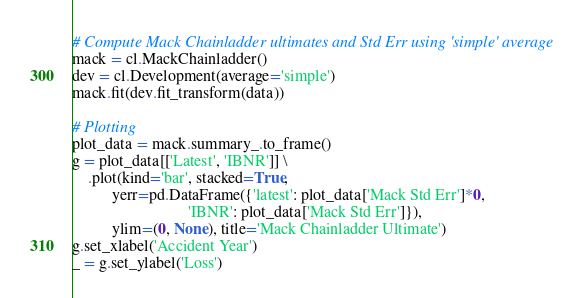Convert code to text. <code><loc_0><loc_0><loc_500><loc_500><_Python_>
# Compute Mack Chainladder ultimates and Std Err using 'simple' average
mack = cl.MackChainladder()
dev = cl.Development(average='simple')
mack.fit(dev.fit_transform(data))

# Plotting
plot_data = mack.summary_.to_frame()
g = plot_data[['Latest', 'IBNR']] \
    .plot(kind='bar', stacked=True,
          yerr=pd.DataFrame({'latest': plot_data['Mack Std Err']*0,
                             'IBNR': plot_data['Mack Std Err']}),
          ylim=(0, None), title='Mack Chainladder Ultimate')
g.set_xlabel('Accident Year')
_ = g.set_ylabel('Loss')
</code> 